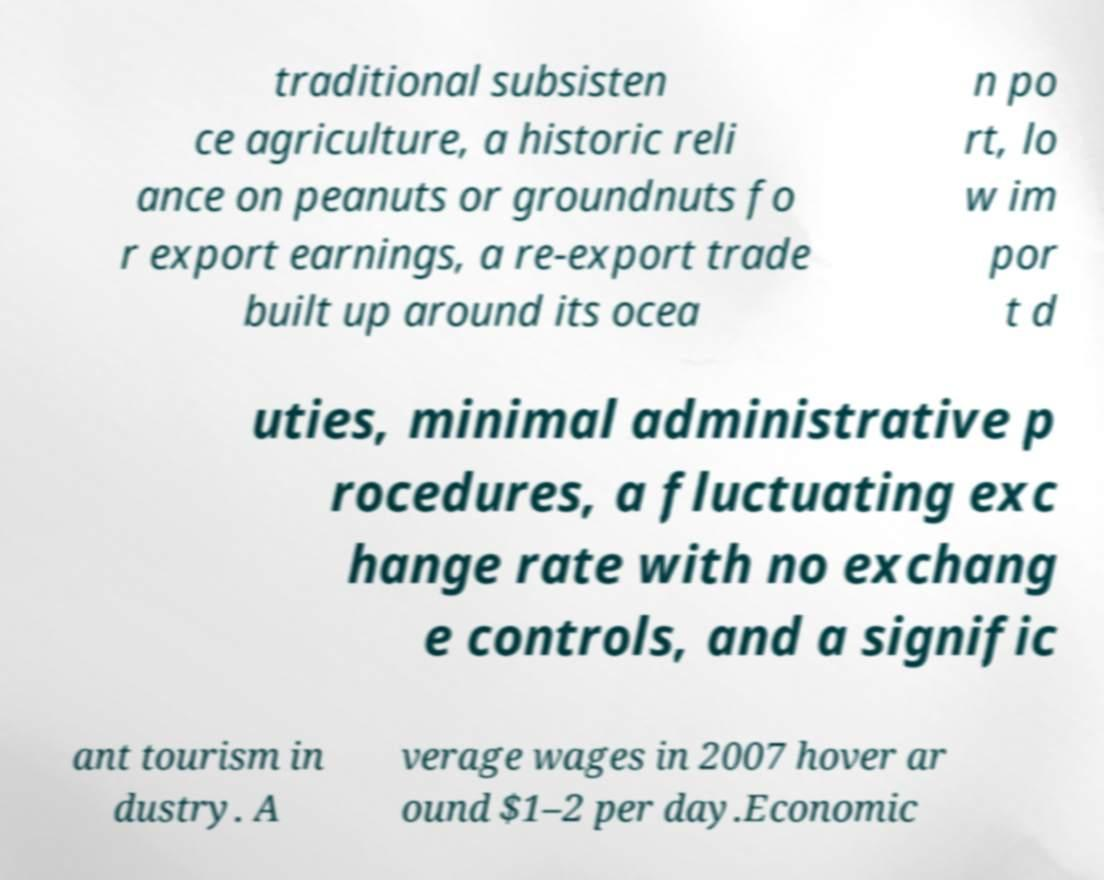Please read and relay the text visible in this image. What does it say? traditional subsisten ce agriculture, a historic reli ance on peanuts or groundnuts fo r export earnings, a re-export trade built up around its ocea n po rt, lo w im por t d uties, minimal administrative p rocedures, a fluctuating exc hange rate with no exchang e controls, and a signific ant tourism in dustry. A verage wages in 2007 hover ar ound $1–2 per day.Economic 